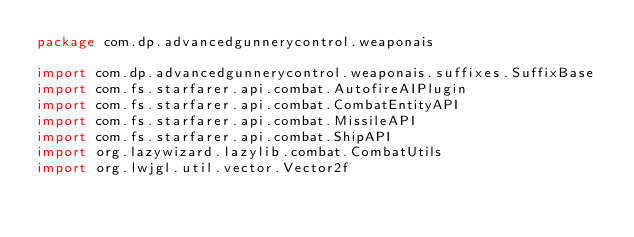Convert code to text. <code><loc_0><loc_0><loc_500><loc_500><_Kotlin_>package com.dp.advancedgunnerycontrol.weaponais

import com.dp.advancedgunnerycontrol.weaponais.suffixes.SuffixBase
import com.fs.starfarer.api.combat.AutofireAIPlugin
import com.fs.starfarer.api.combat.CombatEntityAPI
import com.fs.starfarer.api.combat.MissileAPI
import com.fs.starfarer.api.combat.ShipAPI
import org.lazywizard.lazylib.combat.CombatUtils
import org.lwjgl.util.vector.Vector2f
</code> 